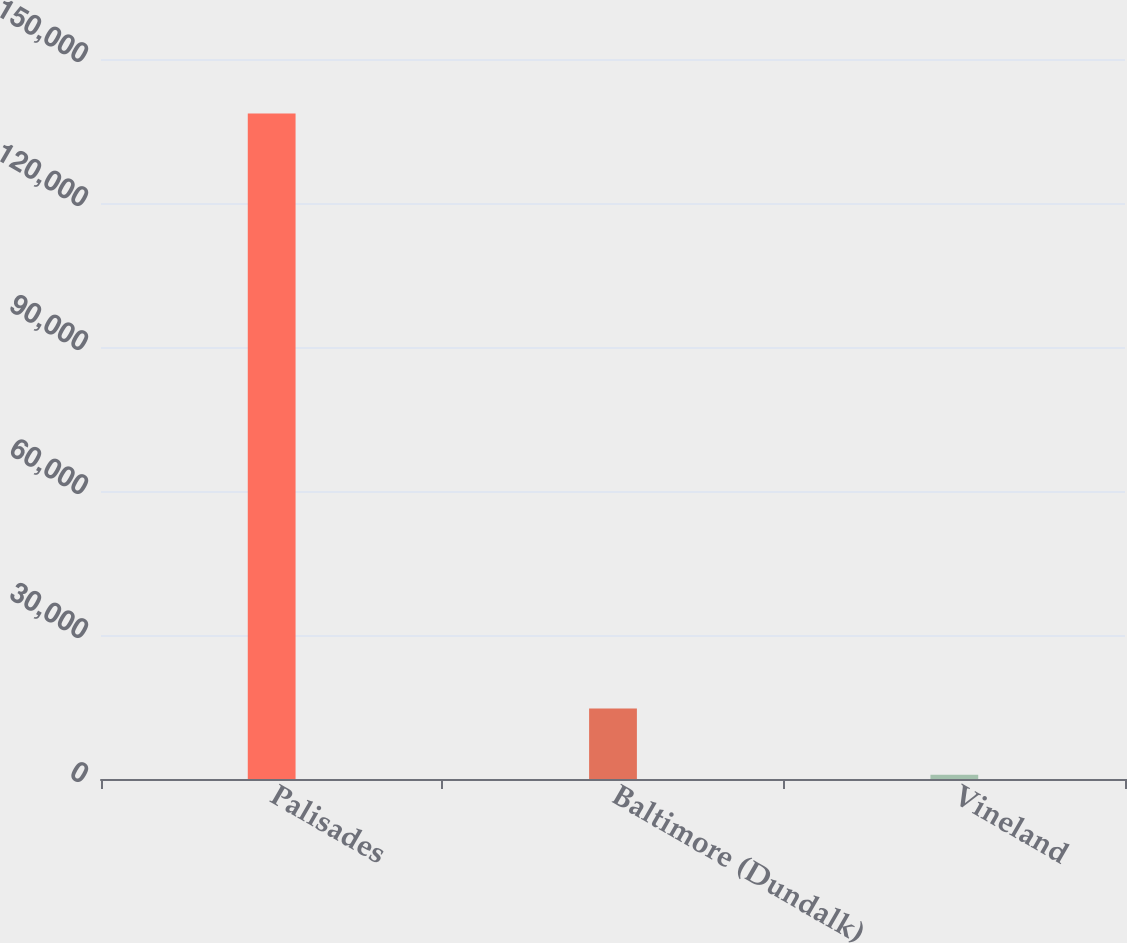Convert chart to OTSL. <chart><loc_0><loc_0><loc_500><loc_500><bar_chart><fcel>Palisades<fcel>Baltimore (Dundalk)<fcel>Vineland<nl><fcel>138629<fcel>14680.1<fcel>908<nl></chart> 